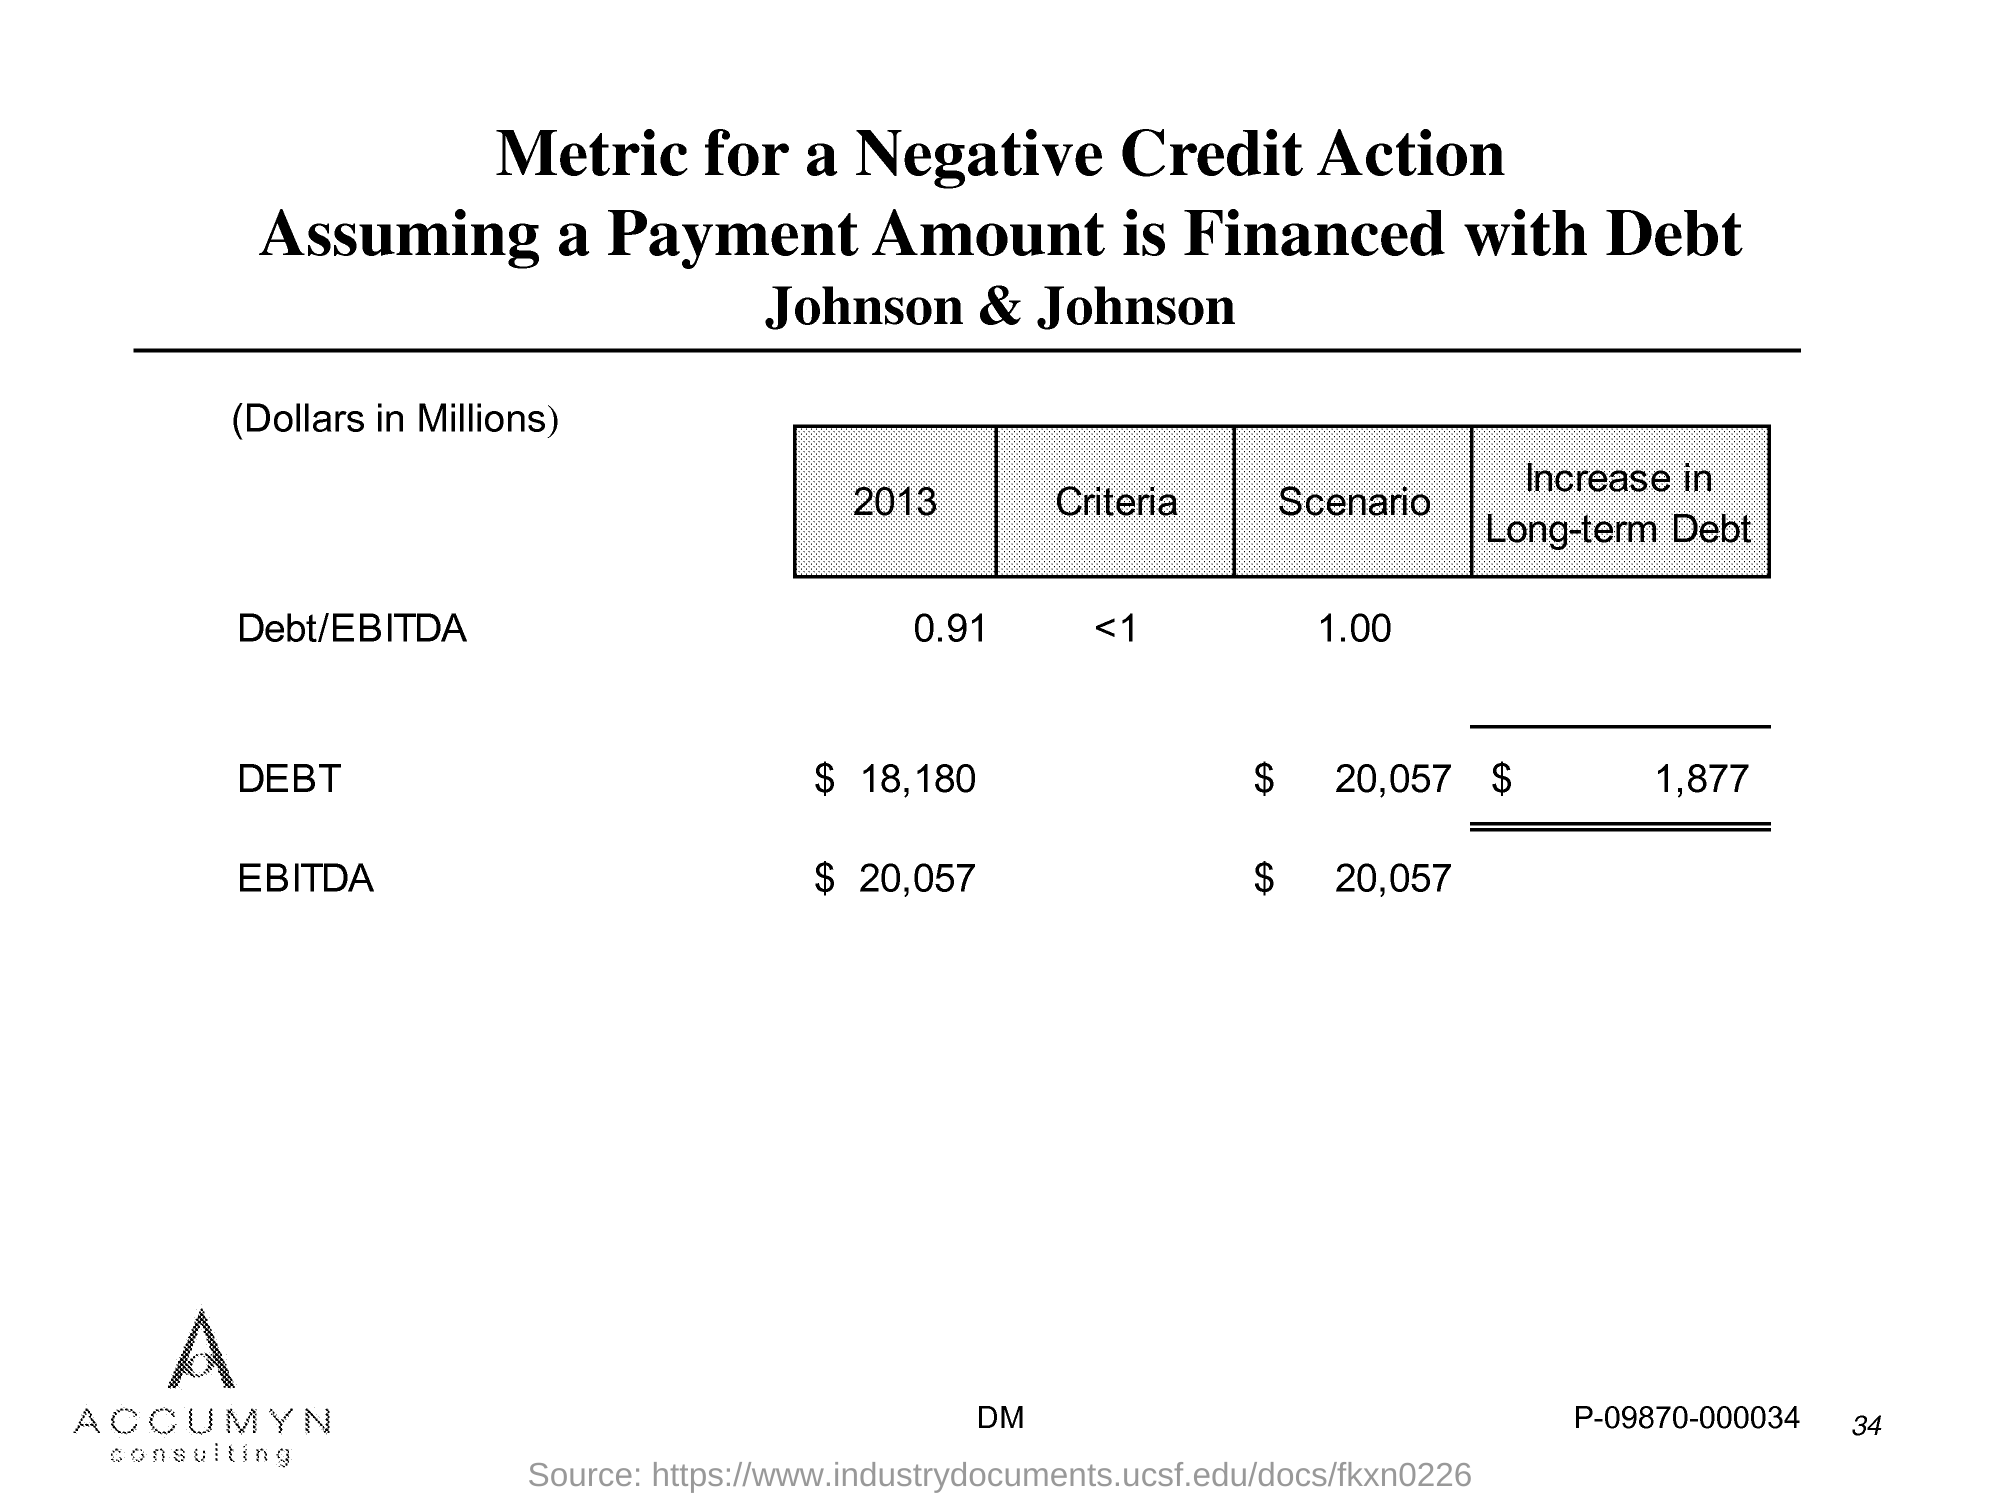Identify some key points in this picture. The page number is 34. 